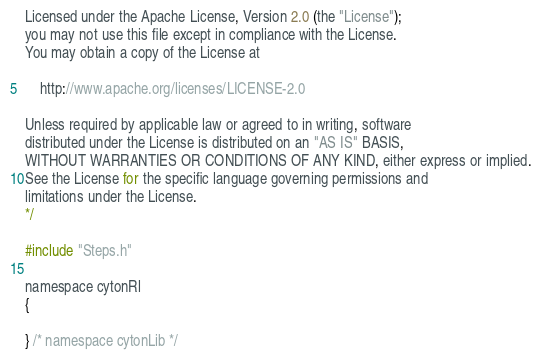<code> <loc_0><loc_0><loc_500><loc_500><_Cuda_>Licensed under the Apache License, Version 2.0 (the "License");
you may not use this file except in compliance with the License.
You may obtain a copy of the License at

    http://www.apache.org/licenses/LICENSE-2.0

Unless required by applicable law or agreed to in writing, software
distributed under the License is distributed on an "AS IS" BASIS,
WITHOUT WARRANTIES OR CONDITIONS OF ANY KIND, either express or implied.
See the License for the specific language governing permissions and
limitations under the License.
*/

#include "Steps.h"

namespace cytonRl
{

} /* namespace cytonLib */
</code> 